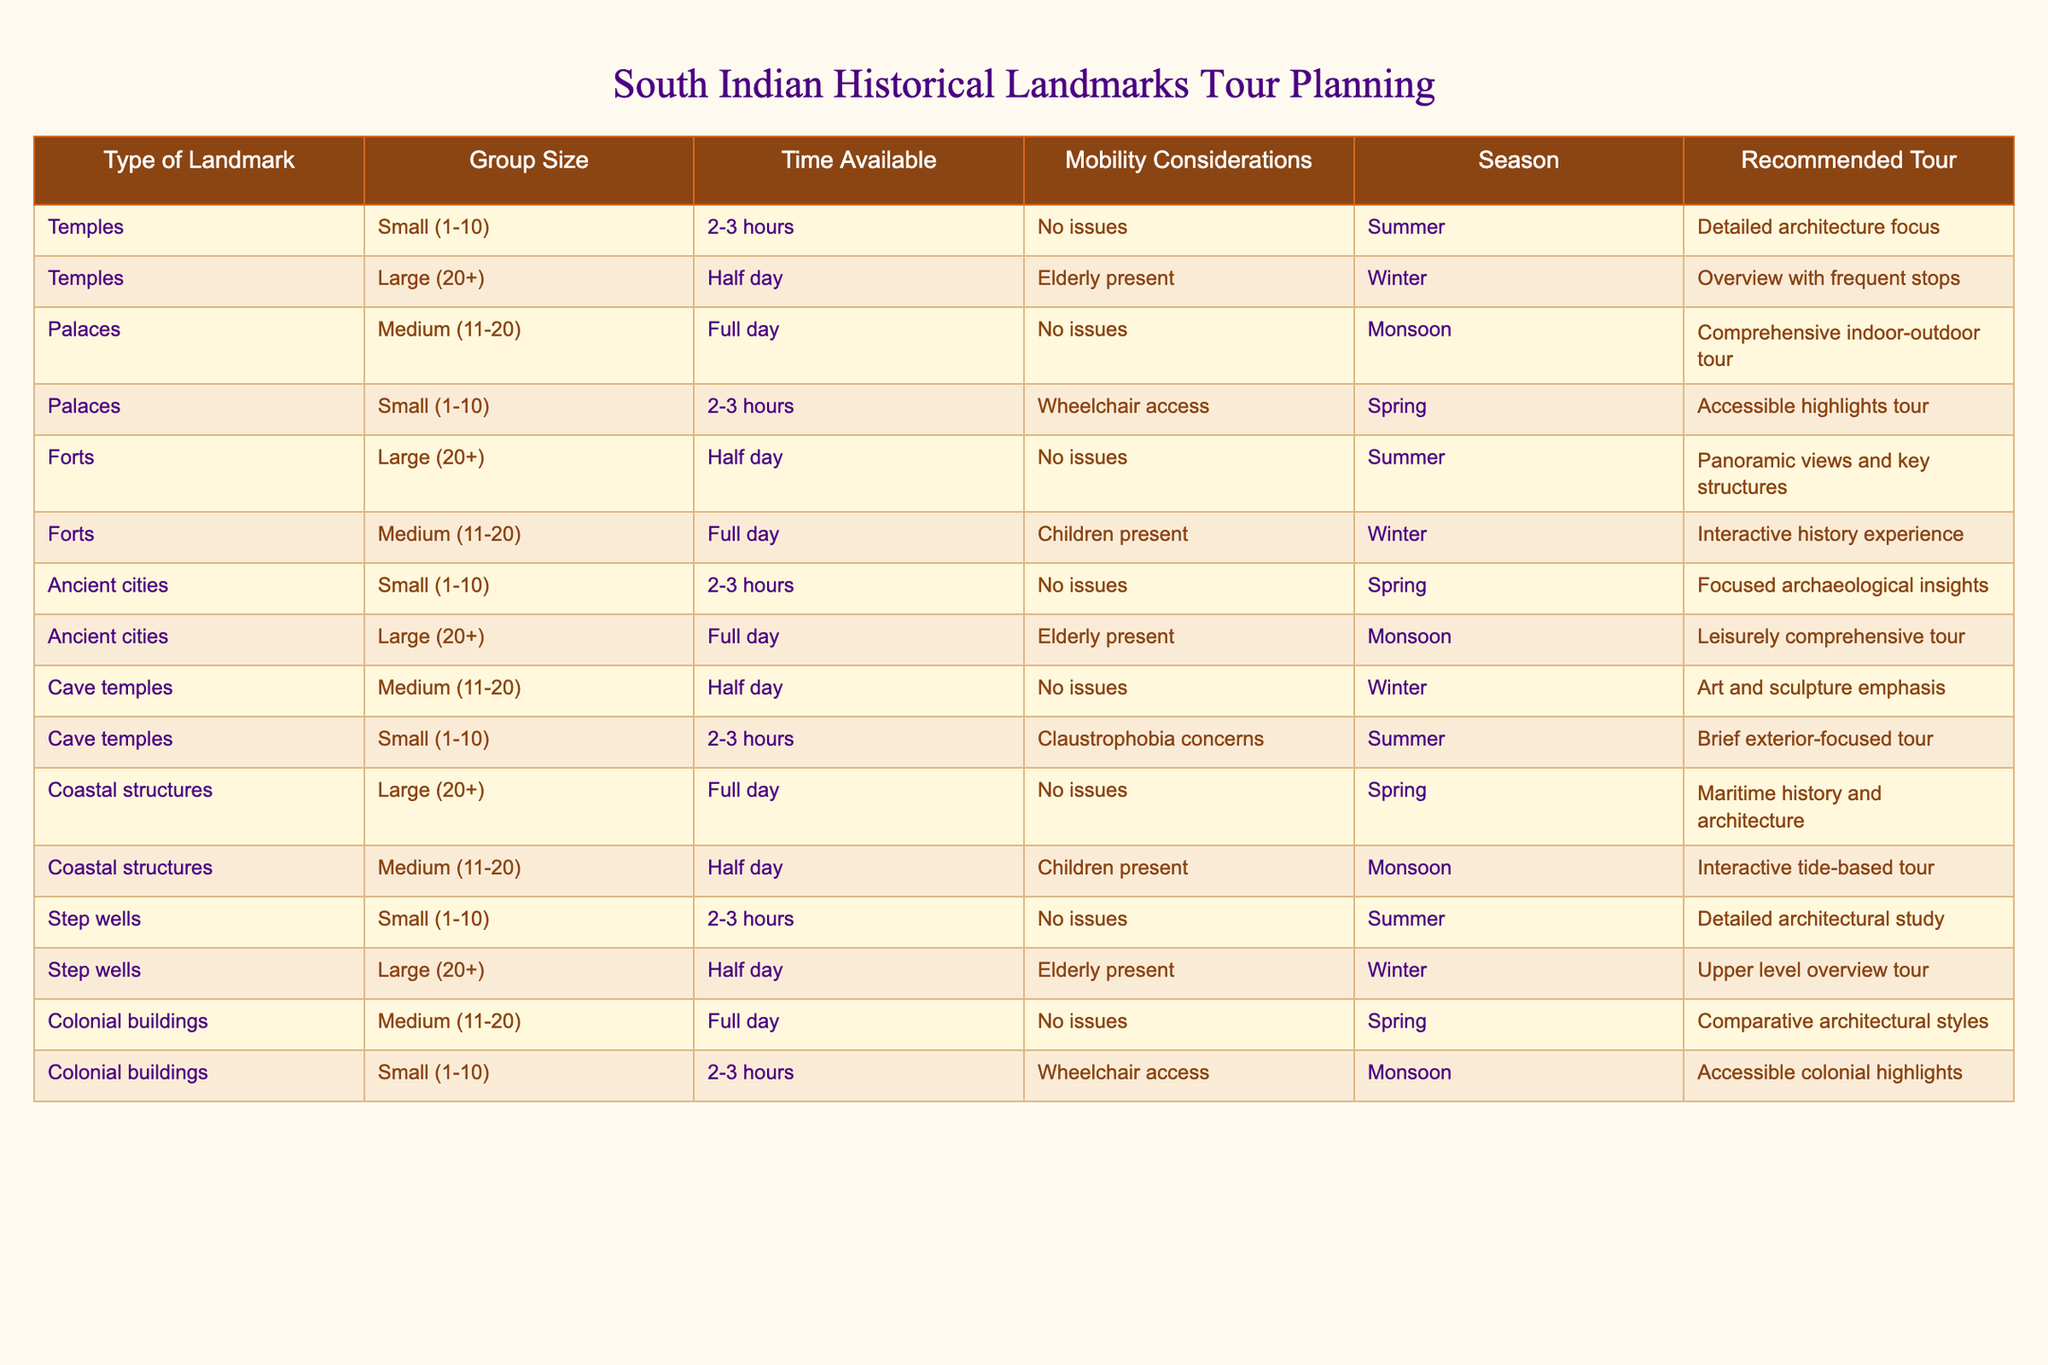What is the recommended tour for small groups visiting forts in the summer? According to the table, for large groups visiting forts in the summer, the recommended tour is "Panoramic views and key structures." Since the question specifies small groups, there is no corresponding entry for small groups in that condition. Therefore, we conclude that there is no specific recommendation for small groups visiting forts in summer.
Answer: No recommendation What type of tours are recommended for large groups visiting ancient cities during the monsoon? The table shows that for large groups visiting ancient cities in the monsoon, the recommended tour is "Leisurely comprehensive tour."
Answer: Leisurely comprehensive tour How many total types of landmarks have a detail-oriented tour? The table shows that three types of landmarks have a focused or detailed aspect in their recommended tours: Temples with "Detailed architecture focus," Step wells with "Detailed architectural study," and Ancient cities with "Focused archaeological insights." Thus, the total is three.
Answer: 3 Are all small group tours accessible for individuals with mobility issues? From the table, we can see that small group tours for Colonial buildings are accessible (wheelchair access), while other small group tours for Forts and Temples do not specify accessibility for mobility issues. Thus, not all small group tours are specifically accessible for individuals with mobility issues.
Answer: No What is the average group size for recommended tours in the spring? The table presents the following recommendations for spring: Temples (Small), Palaces (Small), Ancient cities (Small), and Colonial buildings (Small). To find the average size, we sum the sizes: 10 (Small) + 10 (Small) + 10 (Small) + 10 (Small) = 40, and then divide by 4 (the number of data points), yielding an average group size of 10.
Answer: 10 